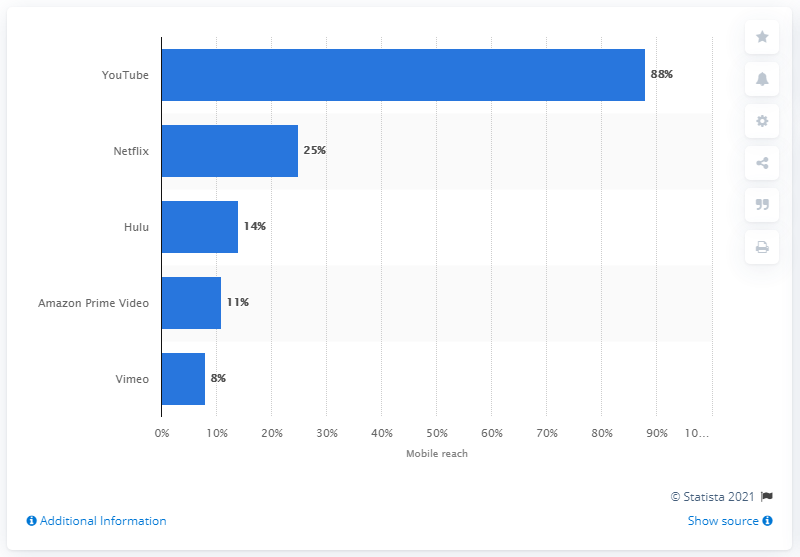Mention a couple of crucial points in this snapshot. Amazon Prime Video had more than double the mobile reach of Netflix. 